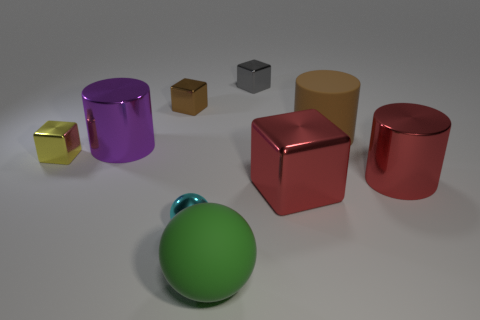There is a red metal thing that is the same shape as the tiny yellow object; what size is it?
Your answer should be compact. Large. The thing that is to the right of the cyan metallic ball and in front of the large cube is what color?
Your answer should be very brief. Green. Do the red block and the brown thing to the right of the big ball have the same material?
Make the answer very short. No. Are there fewer shiny objects that are in front of the tiny yellow object than big gray objects?
Keep it short and to the point. No. How many other objects are there of the same shape as the small yellow metallic thing?
Offer a very short reply. 3. Are there any other things of the same color as the large sphere?
Provide a short and direct response. No. Do the large block and the shiny cylinder that is in front of the purple metal cylinder have the same color?
Provide a short and direct response. Yes. What number of other things are there of the same size as the brown cylinder?
Make the answer very short. 4. There is a shiny cylinder that is the same color as the big cube; what size is it?
Make the answer very short. Large. What number of blocks are cyan shiny things or red metal things?
Provide a short and direct response. 1. 